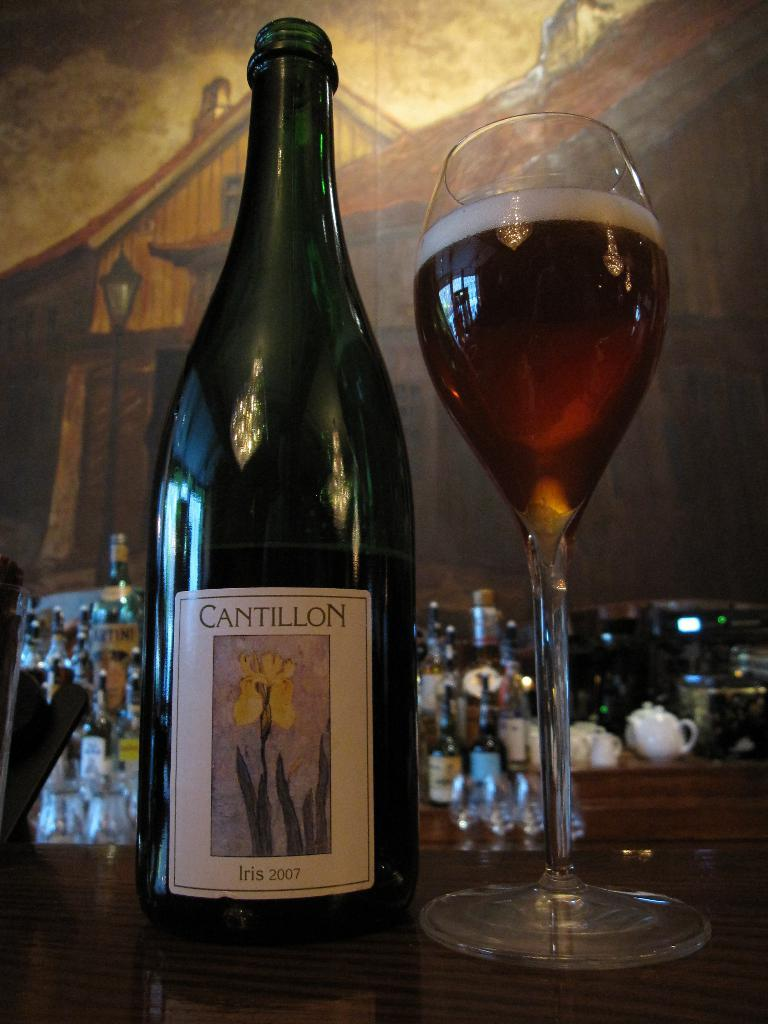What is placed on the table in the image? There is a bottle and a glass with a drink on the table. What can be seen in the background of the image? There are bottles, glasses, teapots, and a wall with a painting in the background. How many teapots are visible in the background? There are teapots in the background, but the exact number is not specified. What type of sock is hanging on the painting in the image? There is no sock present in the image; it features a bottle, a glass with a drink, and various objects in the background. How many haircuts are visible in the image? There are no haircuts visible in the image; it features a bottle, a glass with a drink, and various objects in the background. 